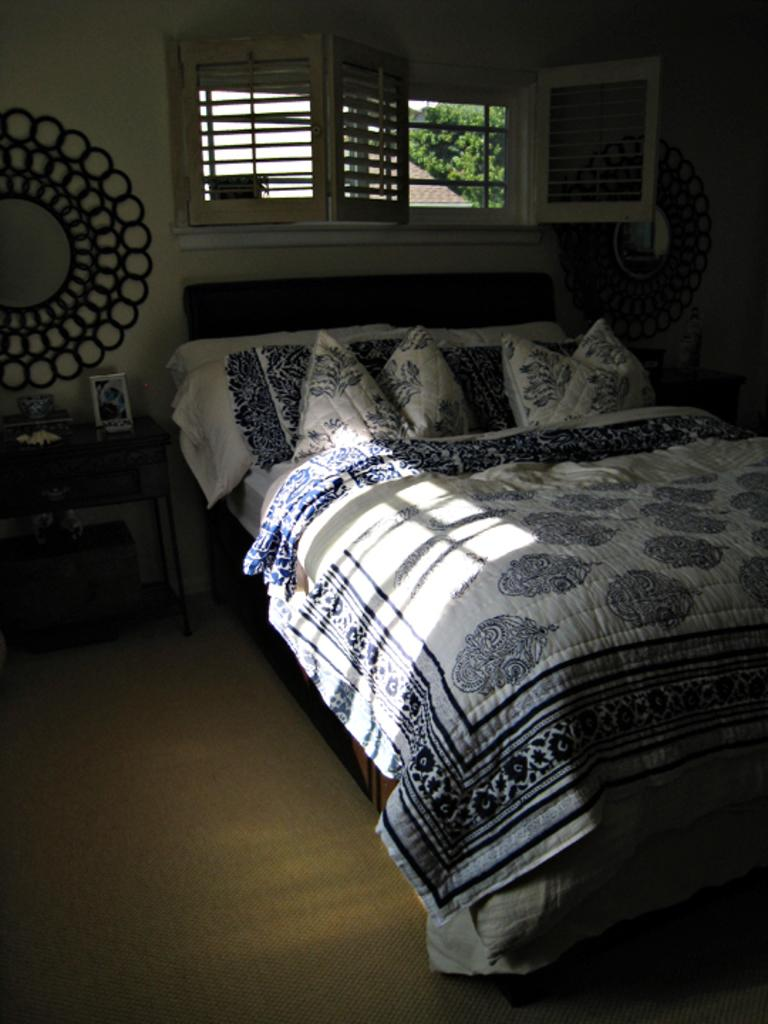What type of room is shown in the image? The image depicts a bedroom. Where is the bed located in the room? The bed is at the right side of the image. What can be seen in the center of the image? There are windows at the center of the image. What piece of furniture is located at the left side of the image? There is a desk at the left side of the image. What type of clouds can be seen through the windows in the image? There is no mention of clouds in the provided facts, and the image does not show any clouds through the windows. 